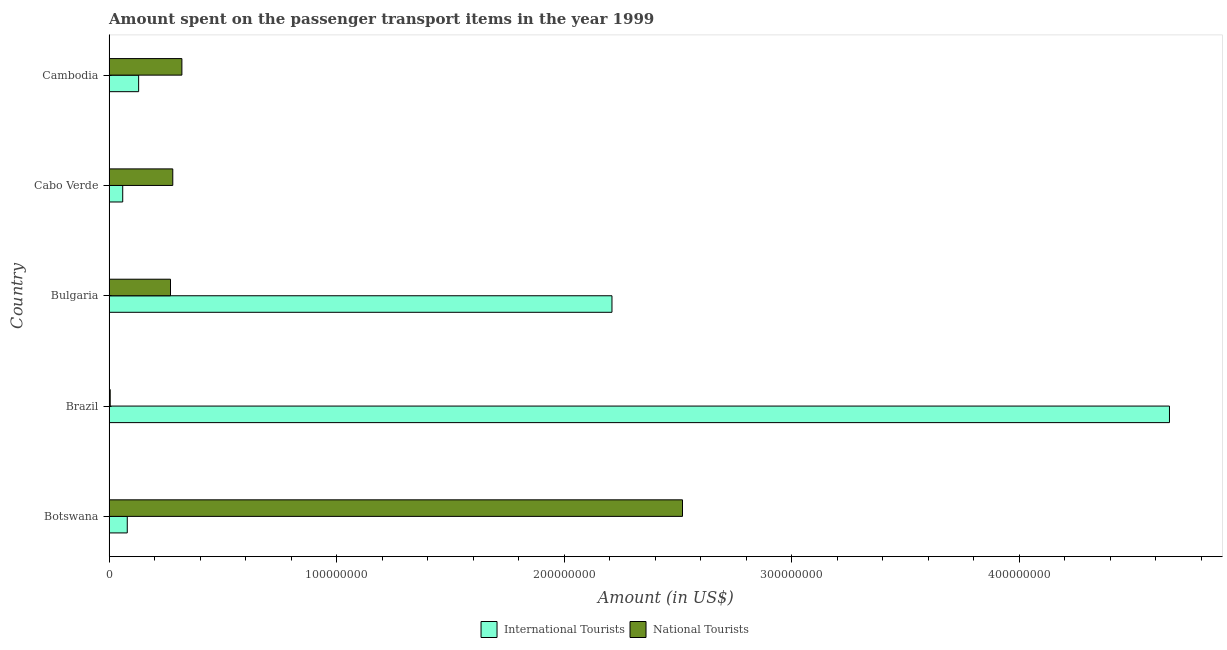How many groups of bars are there?
Your response must be concise. 5. Are the number of bars per tick equal to the number of legend labels?
Provide a short and direct response. Yes. Are the number of bars on each tick of the Y-axis equal?
Ensure brevity in your answer.  Yes. How many bars are there on the 4th tick from the top?
Offer a very short reply. 2. How many bars are there on the 2nd tick from the bottom?
Offer a very short reply. 2. What is the label of the 3rd group of bars from the top?
Give a very brief answer. Bulgaria. What is the amount spent on transport items of international tourists in Cabo Verde?
Your answer should be very brief. 6.00e+06. Across all countries, what is the maximum amount spent on transport items of international tourists?
Your answer should be very brief. 4.66e+08. Across all countries, what is the minimum amount spent on transport items of national tourists?
Ensure brevity in your answer.  5.00e+05. In which country was the amount spent on transport items of national tourists maximum?
Your answer should be compact. Botswana. In which country was the amount spent on transport items of national tourists minimum?
Offer a very short reply. Brazil. What is the total amount spent on transport items of national tourists in the graph?
Offer a terse response. 3.40e+08. What is the difference between the amount spent on transport items of international tourists in Cabo Verde and that in Cambodia?
Your response must be concise. -7.00e+06. What is the difference between the amount spent on transport items of international tourists in Brazil and the amount spent on transport items of national tourists in Cambodia?
Provide a short and direct response. 4.34e+08. What is the average amount spent on transport items of international tourists per country?
Provide a short and direct response. 1.43e+08. What is the difference between the amount spent on transport items of national tourists and amount spent on transport items of international tourists in Brazil?
Provide a short and direct response. -4.66e+08. In how many countries, is the amount spent on transport items of international tourists greater than 20000000 US$?
Make the answer very short. 2. What is the ratio of the amount spent on transport items of international tourists in Botswana to that in Cambodia?
Your response must be concise. 0.61. Is the difference between the amount spent on transport items of international tourists in Botswana and Bulgaria greater than the difference between the amount spent on transport items of national tourists in Botswana and Bulgaria?
Ensure brevity in your answer.  No. What is the difference between the highest and the second highest amount spent on transport items of national tourists?
Keep it short and to the point. 2.20e+08. What is the difference between the highest and the lowest amount spent on transport items of national tourists?
Offer a very short reply. 2.52e+08. What does the 1st bar from the top in Botswana represents?
Provide a succinct answer. National Tourists. What does the 2nd bar from the bottom in Cabo Verde represents?
Provide a short and direct response. National Tourists. How many bars are there?
Ensure brevity in your answer.  10. Are all the bars in the graph horizontal?
Make the answer very short. Yes. How many countries are there in the graph?
Provide a short and direct response. 5. Are the values on the major ticks of X-axis written in scientific E-notation?
Make the answer very short. No. How many legend labels are there?
Your answer should be very brief. 2. What is the title of the graph?
Give a very brief answer. Amount spent on the passenger transport items in the year 1999. What is the label or title of the X-axis?
Give a very brief answer. Amount (in US$). What is the Amount (in US$) of National Tourists in Botswana?
Provide a succinct answer. 2.52e+08. What is the Amount (in US$) in International Tourists in Brazil?
Offer a very short reply. 4.66e+08. What is the Amount (in US$) of International Tourists in Bulgaria?
Make the answer very short. 2.21e+08. What is the Amount (in US$) of National Tourists in Bulgaria?
Your response must be concise. 2.70e+07. What is the Amount (in US$) in International Tourists in Cabo Verde?
Provide a short and direct response. 6.00e+06. What is the Amount (in US$) in National Tourists in Cabo Verde?
Your answer should be compact. 2.80e+07. What is the Amount (in US$) of International Tourists in Cambodia?
Give a very brief answer. 1.30e+07. What is the Amount (in US$) of National Tourists in Cambodia?
Your answer should be very brief. 3.20e+07. Across all countries, what is the maximum Amount (in US$) of International Tourists?
Your response must be concise. 4.66e+08. Across all countries, what is the maximum Amount (in US$) of National Tourists?
Make the answer very short. 2.52e+08. Across all countries, what is the minimum Amount (in US$) in National Tourists?
Provide a succinct answer. 5.00e+05. What is the total Amount (in US$) in International Tourists in the graph?
Your response must be concise. 7.14e+08. What is the total Amount (in US$) in National Tourists in the graph?
Offer a very short reply. 3.40e+08. What is the difference between the Amount (in US$) of International Tourists in Botswana and that in Brazil?
Provide a succinct answer. -4.58e+08. What is the difference between the Amount (in US$) in National Tourists in Botswana and that in Brazil?
Offer a very short reply. 2.52e+08. What is the difference between the Amount (in US$) in International Tourists in Botswana and that in Bulgaria?
Offer a very short reply. -2.13e+08. What is the difference between the Amount (in US$) of National Tourists in Botswana and that in Bulgaria?
Give a very brief answer. 2.25e+08. What is the difference between the Amount (in US$) in International Tourists in Botswana and that in Cabo Verde?
Provide a succinct answer. 2.00e+06. What is the difference between the Amount (in US$) in National Tourists in Botswana and that in Cabo Verde?
Offer a very short reply. 2.24e+08. What is the difference between the Amount (in US$) of International Tourists in Botswana and that in Cambodia?
Provide a succinct answer. -5.00e+06. What is the difference between the Amount (in US$) of National Tourists in Botswana and that in Cambodia?
Your response must be concise. 2.20e+08. What is the difference between the Amount (in US$) in International Tourists in Brazil and that in Bulgaria?
Offer a very short reply. 2.45e+08. What is the difference between the Amount (in US$) of National Tourists in Brazil and that in Bulgaria?
Your answer should be very brief. -2.65e+07. What is the difference between the Amount (in US$) of International Tourists in Brazil and that in Cabo Verde?
Your answer should be compact. 4.60e+08. What is the difference between the Amount (in US$) in National Tourists in Brazil and that in Cabo Verde?
Your answer should be very brief. -2.75e+07. What is the difference between the Amount (in US$) of International Tourists in Brazil and that in Cambodia?
Ensure brevity in your answer.  4.53e+08. What is the difference between the Amount (in US$) in National Tourists in Brazil and that in Cambodia?
Your response must be concise. -3.15e+07. What is the difference between the Amount (in US$) of International Tourists in Bulgaria and that in Cabo Verde?
Provide a succinct answer. 2.15e+08. What is the difference between the Amount (in US$) of International Tourists in Bulgaria and that in Cambodia?
Offer a very short reply. 2.08e+08. What is the difference between the Amount (in US$) of National Tourists in Bulgaria and that in Cambodia?
Make the answer very short. -5.00e+06. What is the difference between the Amount (in US$) in International Tourists in Cabo Verde and that in Cambodia?
Your answer should be very brief. -7.00e+06. What is the difference between the Amount (in US$) of International Tourists in Botswana and the Amount (in US$) of National Tourists in Brazil?
Keep it short and to the point. 7.50e+06. What is the difference between the Amount (in US$) in International Tourists in Botswana and the Amount (in US$) in National Tourists in Bulgaria?
Offer a terse response. -1.90e+07. What is the difference between the Amount (in US$) of International Tourists in Botswana and the Amount (in US$) of National Tourists in Cabo Verde?
Give a very brief answer. -2.00e+07. What is the difference between the Amount (in US$) of International Tourists in Botswana and the Amount (in US$) of National Tourists in Cambodia?
Ensure brevity in your answer.  -2.40e+07. What is the difference between the Amount (in US$) in International Tourists in Brazil and the Amount (in US$) in National Tourists in Bulgaria?
Provide a short and direct response. 4.39e+08. What is the difference between the Amount (in US$) of International Tourists in Brazil and the Amount (in US$) of National Tourists in Cabo Verde?
Keep it short and to the point. 4.38e+08. What is the difference between the Amount (in US$) in International Tourists in Brazil and the Amount (in US$) in National Tourists in Cambodia?
Give a very brief answer. 4.34e+08. What is the difference between the Amount (in US$) of International Tourists in Bulgaria and the Amount (in US$) of National Tourists in Cabo Verde?
Make the answer very short. 1.93e+08. What is the difference between the Amount (in US$) of International Tourists in Bulgaria and the Amount (in US$) of National Tourists in Cambodia?
Provide a succinct answer. 1.89e+08. What is the difference between the Amount (in US$) of International Tourists in Cabo Verde and the Amount (in US$) of National Tourists in Cambodia?
Your answer should be compact. -2.60e+07. What is the average Amount (in US$) of International Tourists per country?
Keep it short and to the point. 1.43e+08. What is the average Amount (in US$) in National Tourists per country?
Make the answer very short. 6.79e+07. What is the difference between the Amount (in US$) in International Tourists and Amount (in US$) in National Tourists in Botswana?
Offer a terse response. -2.44e+08. What is the difference between the Amount (in US$) of International Tourists and Amount (in US$) of National Tourists in Brazil?
Offer a very short reply. 4.66e+08. What is the difference between the Amount (in US$) of International Tourists and Amount (in US$) of National Tourists in Bulgaria?
Offer a terse response. 1.94e+08. What is the difference between the Amount (in US$) of International Tourists and Amount (in US$) of National Tourists in Cabo Verde?
Offer a terse response. -2.20e+07. What is the difference between the Amount (in US$) in International Tourists and Amount (in US$) in National Tourists in Cambodia?
Offer a terse response. -1.90e+07. What is the ratio of the Amount (in US$) of International Tourists in Botswana to that in Brazil?
Offer a terse response. 0.02. What is the ratio of the Amount (in US$) of National Tourists in Botswana to that in Brazil?
Offer a very short reply. 504. What is the ratio of the Amount (in US$) in International Tourists in Botswana to that in Bulgaria?
Offer a very short reply. 0.04. What is the ratio of the Amount (in US$) of National Tourists in Botswana to that in Bulgaria?
Offer a terse response. 9.33. What is the ratio of the Amount (in US$) in International Tourists in Botswana to that in Cabo Verde?
Your answer should be compact. 1.33. What is the ratio of the Amount (in US$) in National Tourists in Botswana to that in Cabo Verde?
Your answer should be compact. 9. What is the ratio of the Amount (in US$) of International Tourists in Botswana to that in Cambodia?
Make the answer very short. 0.62. What is the ratio of the Amount (in US$) in National Tourists in Botswana to that in Cambodia?
Your answer should be compact. 7.88. What is the ratio of the Amount (in US$) in International Tourists in Brazil to that in Bulgaria?
Keep it short and to the point. 2.11. What is the ratio of the Amount (in US$) in National Tourists in Brazil to that in Bulgaria?
Provide a short and direct response. 0.02. What is the ratio of the Amount (in US$) of International Tourists in Brazil to that in Cabo Verde?
Make the answer very short. 77.67. What is the ratio of the Amount (in US$) of National Tourists in Brazil to that in Cabo Verde?
Keep it short and to the point. 0.02. What is the ratio of the Amount (in US$) in International Tourists in Brazil to that in Cambodia?
Offer a terse response. 35.85. What is the ratio of the Amount (in US$) in National Tourists in Brazil to that in Cambodia?
Offer a terse response. 0.02. What is the ratio of the Amount (in US$) of International Tourists in Bulgaria to that in Cabo Verde?
Your answer should be compact. 36.83. What is the ratio of the Amount (in US$) in National Tourists in Bulgaria to that in Cambodia?
Provide a short and direct response. 0.84. What is the ratio of the Amount (in US$) of International Tourists in Cabo Verde to that in Cambodia?
Provide a short and direct response. 0.46. What is the ratio of the Amount (in US$) of National Tourists in Cabo Verde to that in Cambodia?
Keep it short and to the point. 0.88. What is the difference between the highest and the second highest Amount (in US$) in International Tourists?
Offer a terse response. 2.45e+08. What is the difference between the highest and the second highest Amount (in US$) in National Tourists?
Make the answer very short. 2.20e+08. What is the difference between the highest and the lowest Amount (in US$) of International Tourists?
Your answer should be compact. 4.60e+08. What is the difference between the highest and the lowest Amount (in US$) in National Tourists?
Offer a terse response. 2.52e+08. 